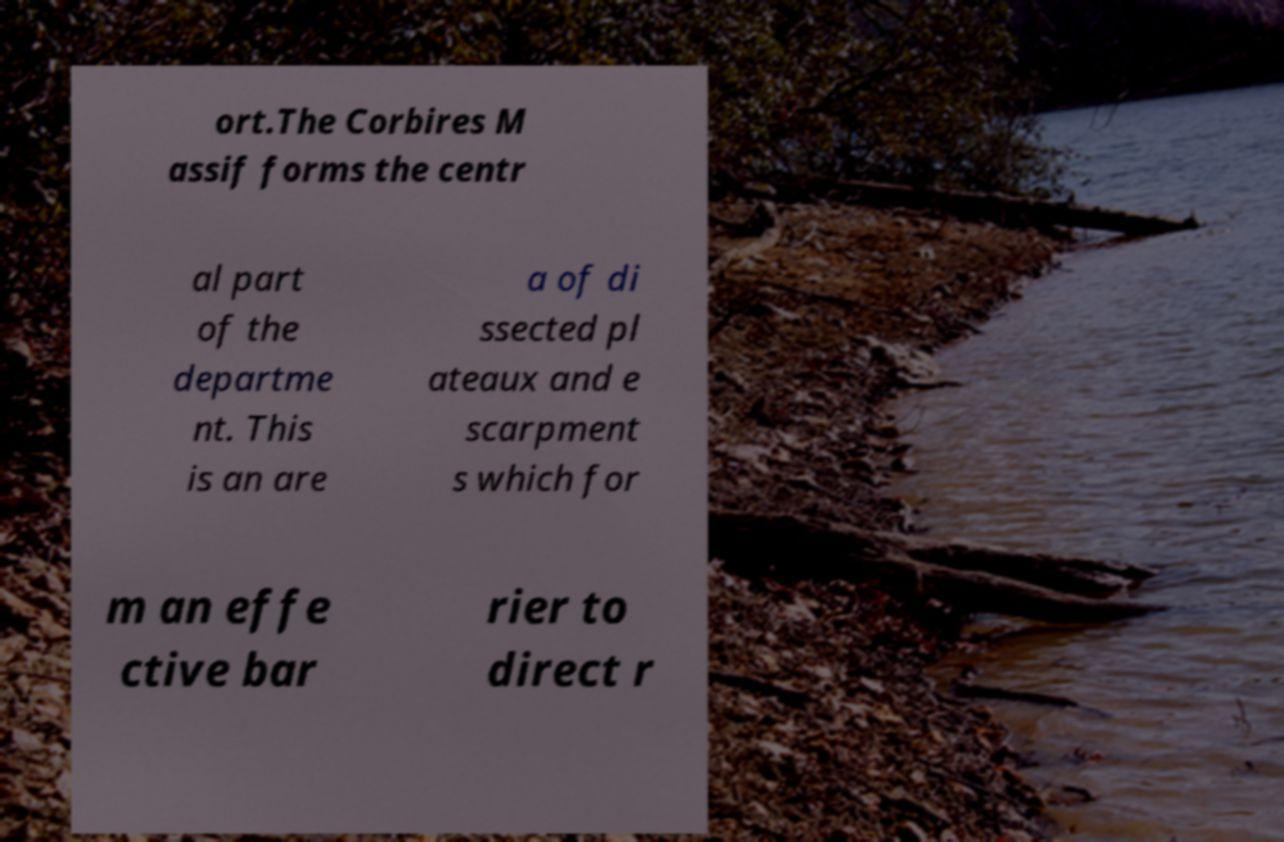Can you read and provide the text displayed in the image?This photo seems to have some interesting text. Can you extract and type it out for me? ort.The Corbires M assif forms the centr al part of the departme nt. This is an are a of di ssected pl ateaux and e scarpment s which for m an effe ctive bar rier to direct r 